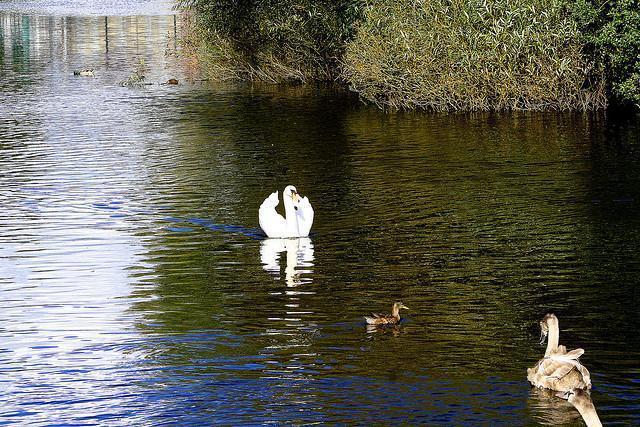How many birds are in the picture?
Give a very brief answer. 3. 